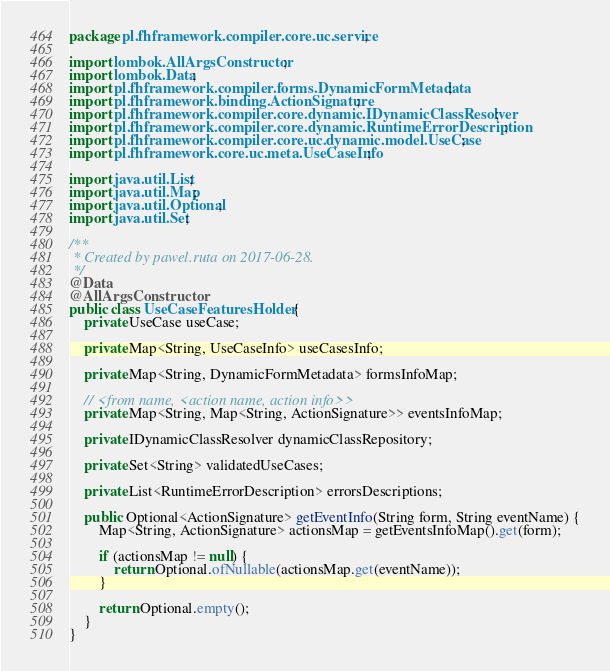Convert code to text. <code><loc_0><loc_0><loc_500><loc_500><_Java_>package pl.fhframework.compiler.core.uc.service;

import lombok.AllArgsConstructor;
import lombok.Data;
import pl.fhframework.compiler.forms.DynamicFormMetadata;
import pl.fhframework.binding.ActionSignature;
import pl.fhframework.compiler.core.dynamic.IDynamicClassResolver;
import pl.fhframework.compiler.core.dynamic.RuntimeErrorDescription;
import pl.fhframework.compiler.core.uc.dynamic.model.UseCase;
import pl.fhframework.core.uc.meta.UseCaseInfo;

import java.util.List;
import java.util.Map;
import java.util.Optional;
import java.util.Set;

/**
 * Created by pawel.ruta on 2017-06-28.
 */
@Data
@AllArgsConstructor
public class UseCaseFeaturesHolder {
    private UseCase useCase;

    private Map<String, UseCaseInfo> useCasesInfo;

    private Map<String, DynamicFormMetadata> formsInfoMap;

    // <from name, <action name, action info>>
    private Map<String, Map<String, ActionSignature>> eventsInfoMap;

    private IDynamicClassResolver dynamicClassRepository;

    private Set<String> validatedUseCases;

    private List<RuntimeErrorDescription> errorsDescriptions;

    public Optional<ActionSignature> getEventInfo(String form, String eventName) {
        Map<String, ActionSignature> actionsMap = getEventsInfoMap().get(form);

        if (actionsMap != null) {
            return Optional.ofNullable(actionsMap.get(eventName));
        }

        return Optional.empty();
    }
}
</code> 